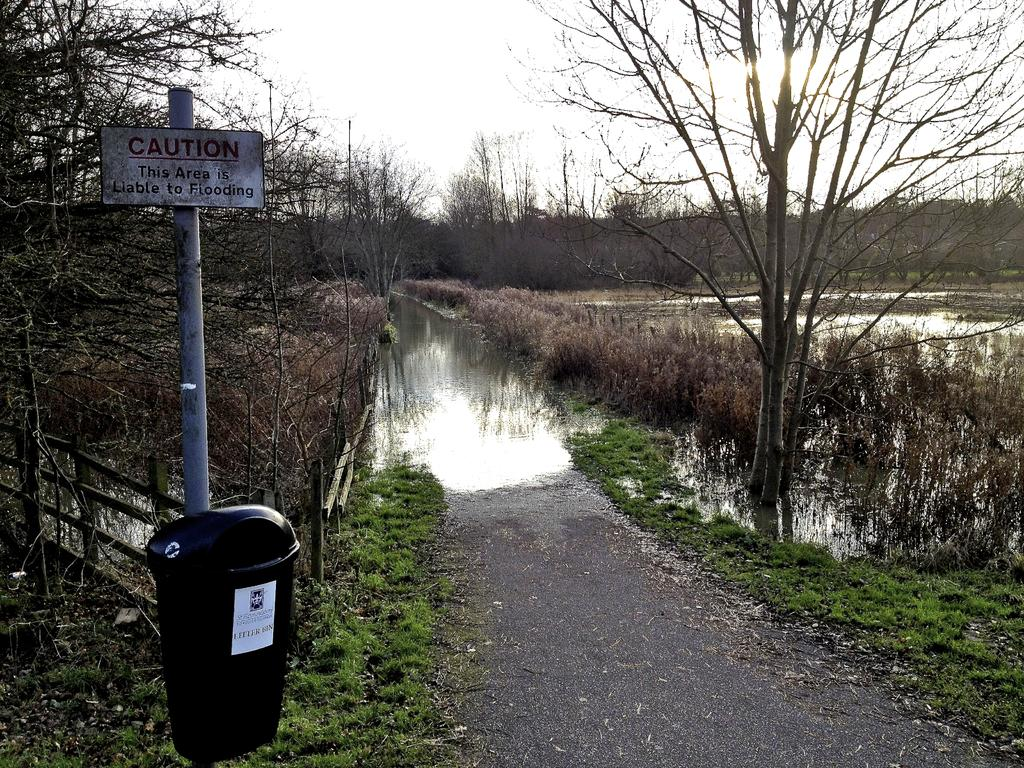Provide a one-sentence caption for the provided image. a flooded road and field with a sign saying "Caution this area is liable to flooding". 